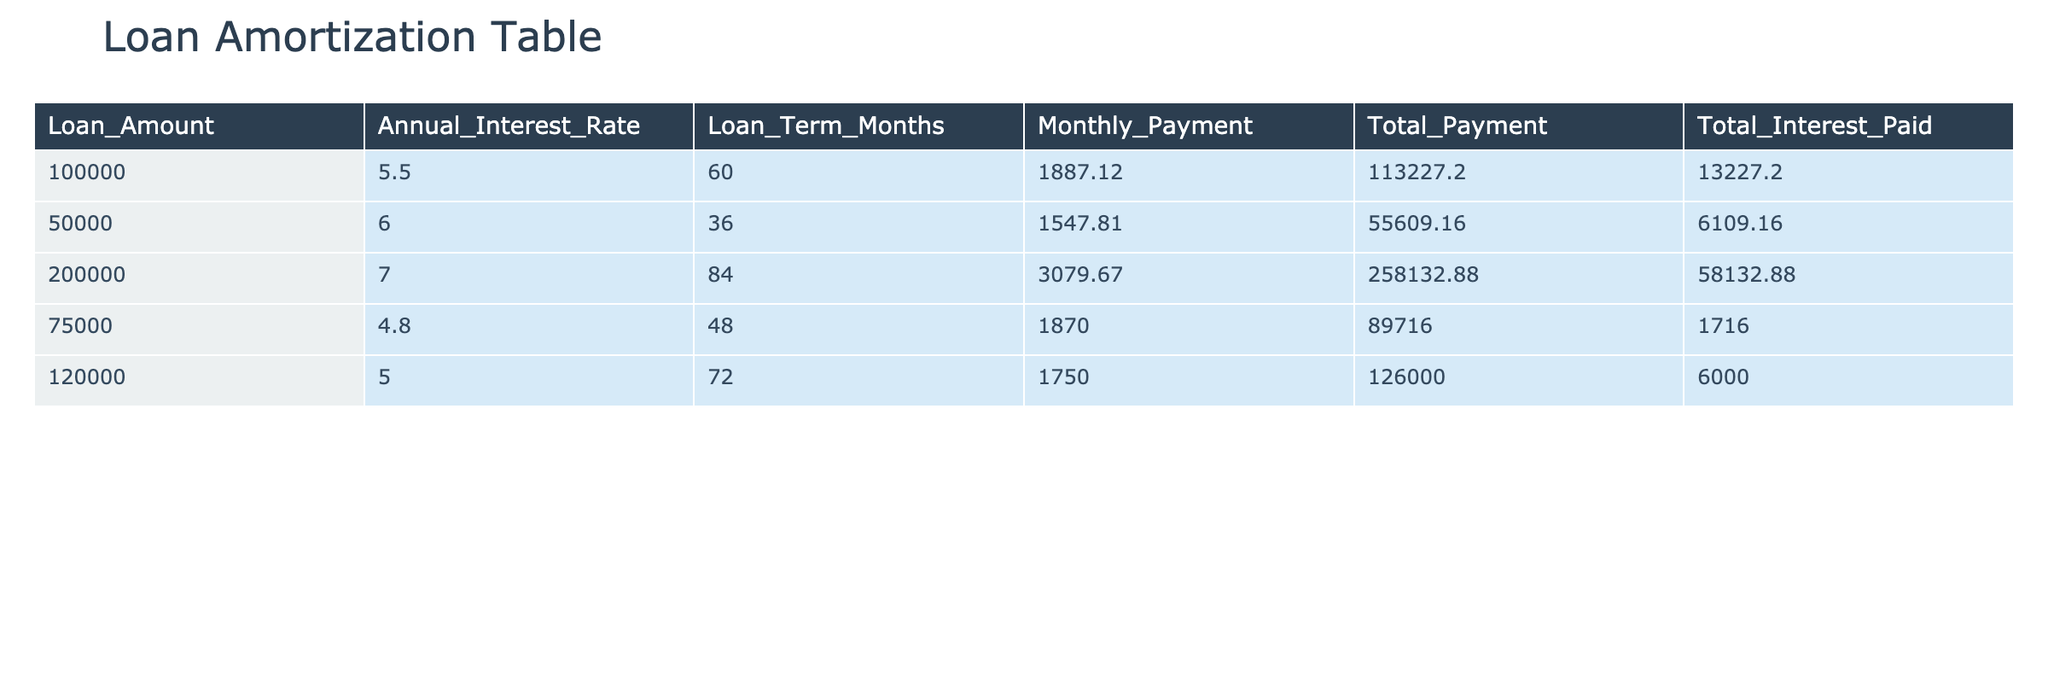What is the loan amount for the financing with the highest total interest paid? The highest total interest paid is 58132.88, which corresponds to the loan amount of 200000.
Answer: 200000 How much will a tech startup pay in total for a loan of 75000? The total payment for the loan of 75000 is 89716.00.
Answer: 89716.00 What is the average monthly payment across all loans? To find the average monthly payment, sum the monthly payments (1887.12 + 1547.81 + 3079.67 + 1870.00 + 1750.00 = 11134.60) and then divide by the number of loans (5), which equals 11134.60 / 5 = 2226.92.
Answer: 2226.92 Is the total payment for a loan of 50000 greater than the total payment for a loan of 75000? The total payment for the loan of 50000 is 55609.16, and for the loan of 75000, it is 89716.00. Thus, 55609.16 is less than 89716.00, making the statement false.
Answer: No What is the difference in total payment between the loan with the smallest monthly payment and the loan with the largest monthly payment? The smallest monthly payment is 1547.81 for the loan of 50000 with a total payment of 55609.16, and the largest monthly payment is 3079.67 for the loan of 200000 with a total payment of 258132.88. The difference in total payments is 258132.88 - 55609.16 = 202523.72.
Answer: 202523.72 Which loan has the shortest term and what is the associated total interest paid? The loan with the shortest term is for 50000, which has a loan term of 36 months and a total interest paid of 6109.16.
Answer: 6109.16 What is the total interest paid for loans with interest rates under 6%? The loans with interest rates under 6% are 75000 at 4.8% with total interest 1716.00 and 120000 at 5.0% with total interest 6000.00. Summing these gives 1716.00 + 6000.00 = 7716.00.
Answer: 7716.00 Is the monthly payment for the loan of 100000 higher than that for the loan of 120000? The monthly payment for the loan of 100000 is 1887.12, and that for the loan of 120000 is 1750.00. Since 1887.12 is greater than 1750.00, the statement is true.
Answer: Yes 